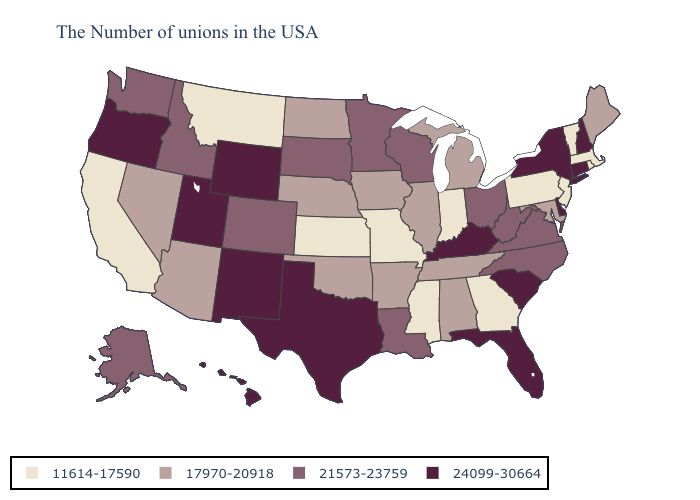Name the states that have a value in the range 11614-17590?
Answer briefly. Massachusetts, Rhode Island, Vermont, New Jersey, Pennsylvania, Georgia, Indiana, Mississippi, Missouri, Kansas, Montana, California. Which states hav the highest value in the Northeast?
Answer briefly. New Hampshire, Connecticut, New York. Does Rhode Island have the lowest value in the Northeast?
Be succinct. Yes. Among the states that border Oregon , which have the highest value?
Short answer required. Idaho, Washington. What is the value of Maryland?
Concise answer only. 17970-20918. Name the states that have a value in the range 24099-30664?
Short answer required. New Hampshire, Connecticut, New York, Delaware, South Carolina, Florida, Kentucky, Texas, Wyoming, New Mexico, Utah, Oregon, Hawaii. What is the highest value in the USA?
Keep it brief. 24099-30664. Among the states that border Virginia , which have the highest value?
Keep it brief. Kentucky. What is the highest value in the USA?
Answer briefly. 24099-30664. What is the value of North Dakota?
Answer briefly. 17970-20918. What is the value of Wyoming?
Short answer required. 24099-30664. Does Texas have the highest value in the USA?
Give a very brief answer. Yes. Name the states that have a value in the range 24099-30664?
Answer briefly. New Hampshire, Connecticut, New York, Delaware, South Carolina, Florida, Kentucky, Texas, Wyoming, New Mexico, Utah, Oregon, Hawaii. How many symbols are there in the legend?
Keep it brief. 4. Which states hav the highest value in the South?
Write a very short answer. Delaware, South Carolina, Florida, Kentucky, Texas. 